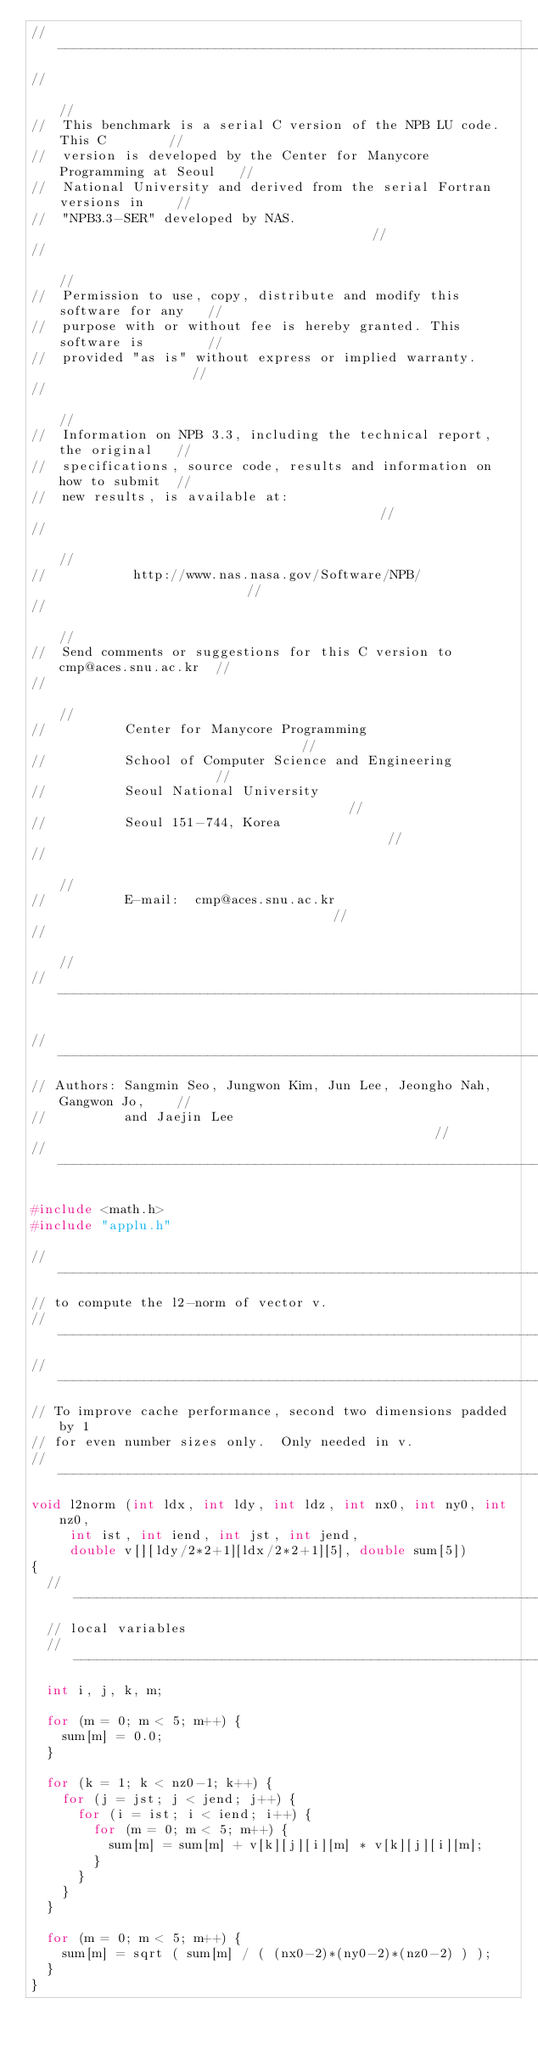Convert code to text. <code><loc_0><loc_0><loc_500><loc_500><_C_>//-------------------------------------------------------------------------//
//                                                                         //
//  This benchmark is a serial C version of the NPB LU code. This C        //
//  version is developed by the Center for Manycore Programming at Seoul   //
//  National University and derived from the serial Fortran versions in    //
//  "NPB3.3-SER" developed by NAS.                                         //
//                                                                         //
//  Permission to use, copy, distribute and modify this software for any   //
//  purpose with or without fee is hereby granted. This software is        //
//  provided "as is" without express or implied warranty.                  //
//                                                                         //
//  Information on NPB 3.3, including the technical report, the original   //
//  specifications, source code, results and information on how to submit  //
//  new results, is available at:                                          //
//                                                                         //
//           http://www.nas.nasa.gov/Software/NPB/                         //
//                                                                         //
//  Send comments or suggestions for this C version to cmp@aces.snu.ac.kr  //
//                                                                         //
//          Center for Manycore Programming                                //
//          School of Computer Science and Engineering                     //
//          Seoul National University                                      //
//          Seoul 151-744, Korea                                           //
//                                                                         //
//          E-mail:  cmp@aces.snu.ac.kr                                    //
//                                                                         //
//-------------------------------------------------------------------------//

//-------------------------------------------------------------------------//
// Authors: Sangmin Seo, Jungwon Kim, Jun Lee, Jeongho Nah, Gangwon Jo,    //
//          and Jaejin Lee                                                 //
//-------------------------------------------------------------------------//

#include <math.h>
#include "applu.h"

//---------------------------------------------------------------------
// to compute the l2-norm of vector v.
//---------------------------------------------------------------------
//---------------------------------------------------------------------
// To improve cache performance, second two dimensions padded by 1 
// for even number sizes only.  Only needed in v.
//---------------------------------------------------------------------
void l2norm (int ldx, int ldy, int ldz, int nx0, int ny0, int nz0,
     int ist, int iend, int jst, int jend,
     double v[][ldy/2*2+1][ldx/2*2+1][5], double sum[5])
{
  //---------------------------------------------------------------------
  // local variables
  //---------------------------------------------------------------------
  int i, j, k, m;

  for (m = 0; m < 5; m++) {
    sum[m] = 0.0;
  }

  for (k = 1; k < nz0-1; k++) {
    for (j = jst; j < jend; j++) {
      for (i = ist; i < iend; i++) {
        for (m = 0; m < 5; m++) {
          sum[m] = sum[m] + v[k][j][i][m] * v[k][j][i][m];
        }
      }
    }
  }

  for (m = 0; m < 5; m++) {
    sum[m] = sqrt ( sum[m] / ( (nx0-2)*(ny0-2)*(nz0-2) ) );
  }
}

</code> 